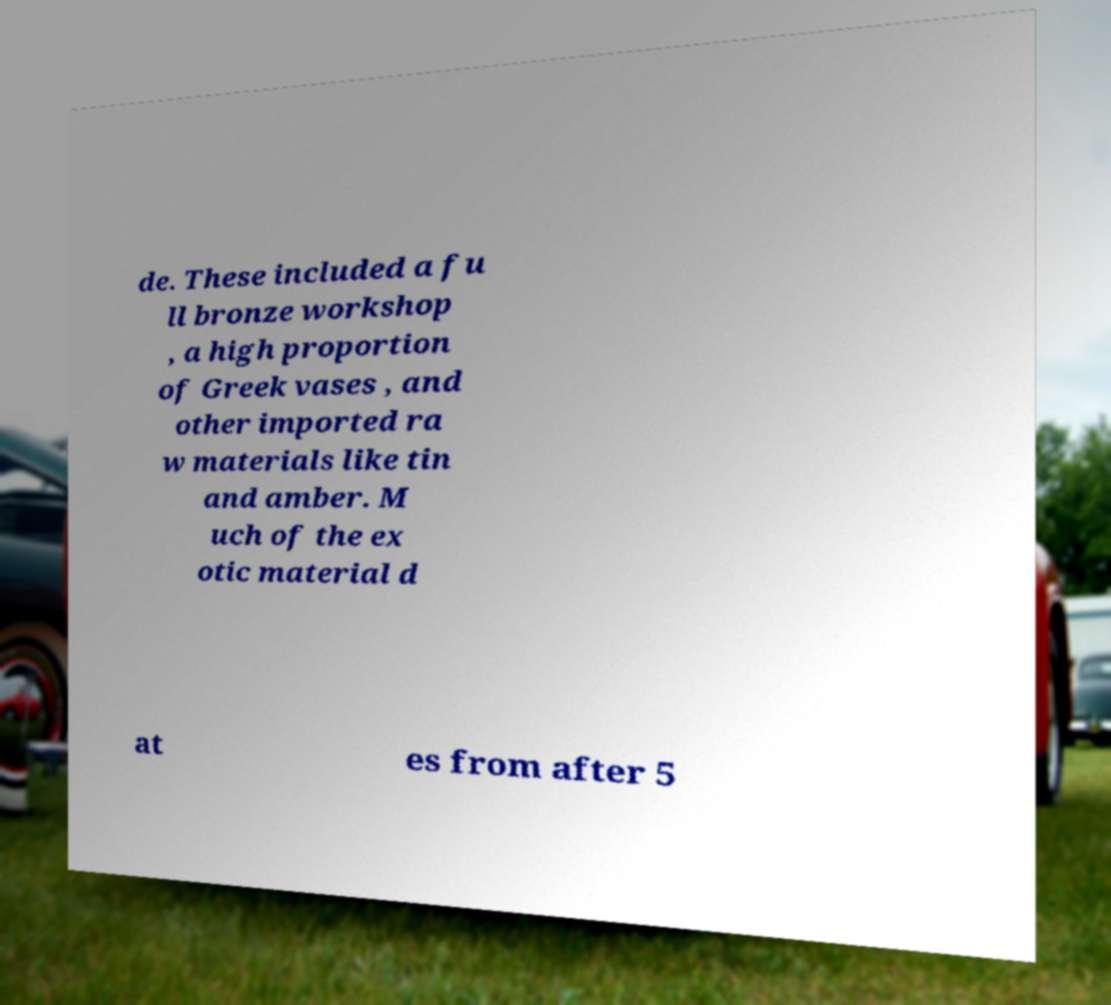Could you extract and type out the text from this image? de. These included a fu ll bronze workshop , a high proportion of Greek vases , and other imported ra w materials like tin and amber. M uch of the ex otic material d at es from after 5 